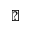<formula> <loc_0><loc_0><loc_500><loc_500>\blacktriangle</formula> 